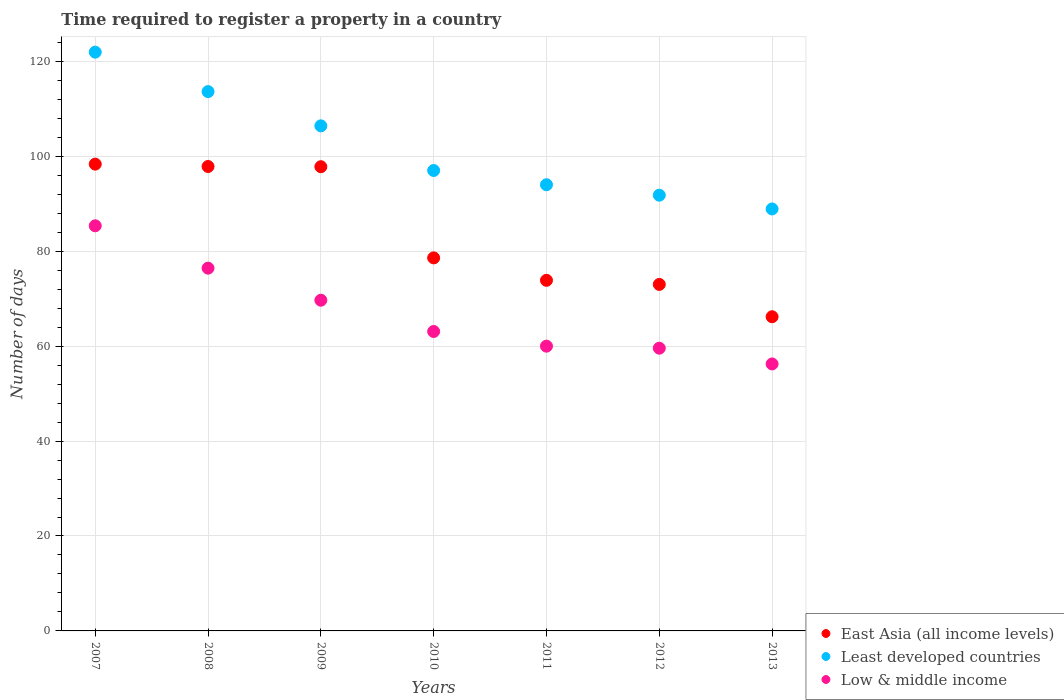How many different coloured dotlines are there?
Keep it short and to the point. 3. What is the number of days required to register a property in East Asia (all income levels) in 2013?
Offer a very short reply. 66.19. Across all years, what is the maximum number of days required to register a property in East Asia (all income levels)?
Your answer should be very brief. 98.34. Across all years, what is the minimum number of days required to register a property in Least developed countries?
Give a very brief answer. 88.9. What is the total number of days required to register a property in Least developed countries in the graph?
Offer a very short reply. 713.65. What is the difference between the number of days required to register a property in East Asia (all income levels) in 2008 and that in 2011?
Your answer should be very brief. 23.98. What is the difference between the number of days required to register a property in Least developed countries in 2011 and the number of days required to register a property in Low & middle income in 2010?
Your answer should be very brief. 30.92. What is the average number of days required to register a property in East Asia (all income levels) per year?
Ensure brevity in your answer.  83.66. In the year 2013, what is the difference between the number of days required to register a property in Least developed countries and number of days required to register a property in Low & middle income?
Provide a short and direct response. 32.65. What is the ratio of the number of days required to register a property in East Asia (all income levels) in 2008 to that in 2010?
Provide a succinct answer. 1.24. Is the difference between the number of days required to register a property in Least developed countries in 2007 and 2013 greater than the difference between the number of days required to register a property in Low & middle income in 2007 and 2013?
Provide a succinct answer. Yes. What is the difference between the highest and the second highest number of days required to register a property in Low & middle income?
Your answer should be compact. 8.92. What is the difference between the highest and the lowest number of days required to register a property in East Asia (all income levels)?
Offer a very short reply. 32.15. Is it the case that in every year, the sum of the number of days required to register a property in Least developed countries and number of days required to register a property in East Asia (all income levels)  is greater than the number of days required to register a property in Low & middle income?
Your answer should be very brief. Yes. Is the number of days required to register a property in Low & middle income strictly greater than the number of days required to register a property in Least developed countries over the years?
Keep it short and to the point. No. How many years are there in the graph?
Your answer should be compact. 7. Does the graph contain grids?
Provide a succinct answer. Yes. How many legend labels are there?
Offer a terse response. 3. How are the legend labels stacked?
Your answer should be compact. Vertical. What is the title of the graph?
Offer a very short reply. Time required to register a property in a country. What is the label or title of the Y-axis?
Offer a terse response. Number of days. What is the Number of days in East Asia (all income levels) in 2007?
Give a very brief answer. 98.34. What is the Number of days in Least developed countries in 2007?
Give a very brief answer. 121.93. What is the Number of days in Low & middle income in 2007?
Make the answer very short. 85.35. What is the Number of days of East Asia (all income levels) in 2008?
Keep it short and to the point. 97.84. What is the Number of days in Least developed countries in 2008?
Your response must be concise. 113.62. What is the Number of days of Low & middle income in 2008?
Your response must be concise. 76.42. What is the Number of days in East Asia (all income levels) in 2009?
Make the answer very short. 97.8. What is the Number of days of Least developed countries in 2009?
Your answer should be very brief. 106.4. What is the Number of days of Low & middle income in 2009?
Offer a terse response. 69.67. What is the Number of days of East Asia (all income levels) in 2010?
Ensure brevity in your answer.  78.59. What is the Number of days of Least developed countries in 2010?
Your answer should be compact. 97. What is the Number of days of Low & middle income in 2010?
Keep it short and to the point. 63.08. What is the Number of days of East Asia (all income levels) in 2011?
Provide a short and direct response. 73.86. What is the Number of days of Least developed countries in 2011?
Your answer should be compact. 94. What is the Number of days of Low & middle income in 2011?
Your answer should be compact. 59.99. What is the Number of days in Least developed countries in 2012?
Offer a very short reply. 91.8. What is the Number of days of Low & middle income in 2012?
Provide a short and direct response. 59.56. What is the Number of days in East Asia (all income levels) in 2013?
Give a very brief answer. 66.19. What is the Number of days in Least developed countries in 2013?
Your answer should be compact. 88.9. What is the Number of days in Low & middle income in 2013?
Provide a short and direct response. 56.25. Across all years, what is the maximum Number of days of East Asia (all income levels)?
Your answer should be very brief. 98.34. Across all years, what is the maximum Number of days in Least developed countries?
Ensure brevity in your answer.  121.93. Across all years, what is the maximum Number of days of Low & middle income?
Your answer should be very brief. 85.35. Across all years, what is the minimum Number of days in East Asia (all income levels)?
Offer a terse response. 66.19. Across all years, what is the minimum Number of days of Least developed countries?
Your response must be concise. 88.9. Across all years, what is the minimum Number of days in Low & middle income?
Provide a succinct answer. 56.25. What is the total Number of days in East Asia (all income levels) in the graph?
Offer a very short reply. 585.62. What is the total Number of days in Least developed countries in the graph?
Your answer should be compact. 713.65. What is the total Number of days in Low & middle income in the graph?
Ensure brevity in your answer.  470.33. What is the difference between the Number of days of Least developed countries in 2007 and that in 2008?
Your answer should be very brief. 8.31. What is the difference between the Number of days in Low & middle income in 2007 and that in 2008?
Provide a succinct answer. 8.92. What is the difference between the Number of days of East Asia (all income levels) in 2007 and that in 2009?
Offer a terse response. 0.55. What is the difference between the Number of days in Least developed countries in 2007 and that in 2009?
Make the answer very short. 15.52. What is the difference between the Number of days of Low & middle income in 2007 and that in 2009?
Provide a short and direct response. 15.68. What is the difference between the Number of days in East Asia (all income levels) in 2007 and that in 2010?
Offer a terse response. 19.75. What is the difference between the Number of days of Least developed countries in 2007 and that in 2010?
Keep it short and to the point. 24.93. What is the difference between the Number of days of Low & middle income in 2007 and that in 2010?
Provide a succinct answer. 22.27. What is the difference between the Number of days of East Asia (all income levels) in 2007 and that in 2011?
Make the answer very short. 24.48. What is the difference between the Number of days of Least developed countries in 2007 and that in 2011?
Make the answer very short. 27.93. What is the difference between the Number of days of Low & middle income in 2007 and that in 2011?
Your answer should be compact. 25.36. What is the difference between the Number of days of East Asia (all income levels) in 2007 and that in 2012?
Keep it short and to the point. 25.34. What is the difference between the Number of days of Least developed countries in 2007 and that in 2012?
Your answer should be very brief. 30.13. What is the difference between the Number of days of Low & middle income in 2007 and that in 2012?
Provide a succinct answer. 25.79. What is the difference between the Number of days of East Asia (all income levels) in 2007 and that in 2013?
Give a very brief answer. 32.15. What is the difference between the Number of days of Least developed countries in 2007 and that in 2013?
Your answer should be very brief. 33.03. What is the difference between the Number of days of Low & middle income in 2007 and that in 2013?
Ensure brevity in your answer.  29.1. What is the difference between the Number of days in East Asia (all income levels) in 2008 and that in 2009?
Provide a short and direct response. 0.05. What is the difference between the Number of days in Least developed countries in 2008 and that in 2009?
Give a very brief answer. 7.21. What is the difference between the Number of days of Low & middle income in 2008 and that in 2009?
Your answer should be very brief. 6.75. What is the difference between the Number of days of East Asia (all income levels) in 2008 and that in 2010?
Your response must be concise. 19.25. What is the difference between the Number of days of Least developed countries in 2008 and that in 2010?
Offer a terse response. 16.62. What is the difference between the Number of days of Low & middle income in 2008 and that in 2010?
Your answer should be very brief. 13.34. What is the difference between the Number of days of East Asia (all income levels) in 2008 and that in 2011?
Offer a very short reply. 23.98. What is the difference between the Number of days in Least developed countries in 2008 and that in 2011?
Offer a terse response. 19.62. What is the difference between the Number of days in Low & middle income in 2008 and that in 2011?
Give a very brief answer. 16.43. What is the difference between the Number of days in East Asia (all income levels) in 2008 and that in 2012?
Make the answer very short. 24.84. What is the difference between the Number of days of Least developed countries in 2008 and that in 2012?
Your answer should be compact. 21.82. What is the difference between the Number of days of Low & middle income in 2008 and that in 2012?
Ensure brevity in your answer.  16.86. What is the difference between the Number of days of East Asia (all income levels) in 2008 and that in 2013?
Ensure brevity in your answer.  31.65. What is the difference between the Number of days in Least developed countries in 2008 and that in 2013?
Keep it short and to the point. 24.72. What is the difference between the Number of days of Low & middle income in 2008 and that in 2013?
Your answer should be very brief. 20.18. What is the difference between the Number of days in East Asia (all income levels) in 2009 and that in 2010?
Keep it short and to the point. 19.2. What is the difference between the Number of days of Least developed countries in 2009 and that in 2010?
Ensure brevity in your answer.  9.4. What is the difference between the Number of days in Low & middle income in 2009 and that in 2010?
Keep it short and to the point. 6.59. What is the difference between the Number of days in East Asia (all income levels) in 2009 and that in 2011?
Your answer should be compact. 23.93. What is the difference between the Number of days in Least developed countries in 2009 and that in 2011?
Offer a terse response. 12.4. What is the difference between the Number of days in Low & middle income in 2009 and that in 2011?
Offer a terse response. 9.68. What is the difference between the Number of days in East Asia (all income levels) in 2009 and that in 2012?
Offer a very short reply. 24.8. What is the difference between the Number of days of Least developed countries in 2009 and that in 2012?
Make the answer very short. 14.61. What is the difference between the Number of days in Low & middle income in 2009 and that in 2012?
Your answer should be very brief. 10.11. What is the difference between the Number of days of East Asia (all income levels) in 2009 and that in 2013?
Your answer should be compact. 31.61. What is the difference between the Number of days of Least developed countries in 2009 and that in 2013?
Offer a very short reply. 17.5. What is the difference between the Number of days of Low & middle income in 2009 and that in 2013?
Your answer should be very brief. 13.43. What is the difference between the Number of days in East Asia (all income levels) in 2010 and that in 2011?
Give a very brief answer. 4.73. What is the difference between the Number of days in Least developed countries in 2010 and that in 2011?
Make the answer very short. 3. What is the difference between the Number of days in Low & middle income in 2010 and that in 2011?
Give a very brief answer. 3.09. What is the difference between the Number of days of East Asia (all income levels) in 2010 and that in 2012?
Your answer should be compact. 5.59. What is the difference between the Number of days of Least developed countries in 2010 and that in 2012?
Offer a very short reply. 5.2. What is the difference between the Number of days of Low & middle income in 2010 and that in 2012?
Your answer should be compact. 3.52. What is the difference between the Number of days in East Asia (all income levels) in 2010 and that in 2013?
Provide a succinct answer. 12.4. What is the difference between the Number of days in Least developed countries in 2010 and that in 2013?
Keep it short and to the point. 8.1. What is the difference between the Number of days in Low & middle income in 2010 and that in 2013?
Your response must be concise. 6.84. What is the difference between the Number of days of East Asia (all income levels) in 2011 and that in 2012?
Your answer should be very brief. 0.86. What is the difference between the Number of days of Least developed countries in 2011 and that in 2012?
Your answer should be very brief. 2.2. What is the difference between the Number of days in Low & middle income in 2011 and that in 2012?
Make the answer very short. 0.43. What is the difference between the Number of days in East Asia (all income levels) in 2011 and that in 2013?
Your response must be concise. 7.68. What is the difference between the Number of days in Least developed countries in 2011 and that in 2013?
Provide a succinct answer. 5.1. What is the difference between the Number of days of Low & middle income in 2011 and that in 2013?
Your answer should be compact. 3.75. What is the difference between the Number of days in East Asia (all income levels) in 2012 and that in 2013?
Provide a succinct answer. 6.81. What is the difference between the Number of days of Least developed countries in 2012 and that in 2013?
Offer a very short reply. 2.9. What is the difference between the Number of days of Low & middle income in 2012 and that in 2013?
Make the answer very short. 3.32. What is the difference between the Number of days of East Asia (all income levels) in 2007 and the Number of days of Least developed countries in 2008?
Your answer should be compact. -15.28. What is the difference between the Number of days of East Asia (all income levels) in 2007 and the Number of days of Low & middle income in 2008?
Provide a succinct answer. 21.92. What is the difference between the Number of days in Least developed countries in 2007 and the Number of days in Low & middle income in 2008?
Provide a succinct answer. 45.5. What is the difference between the Number of days of East Asia (all income levels) in 2007 and the Number of days of Least developed countries in 2009?
Offer a terse response. -8.06. What is the difference between the Number of days of East Asia (all income levels) in 2007 and the Number of days of Low & middle income in 2009?
Your answer should be very brief. 28.67. What is the difference between the Number of days in Least developed countries in 2007 and the Number of days in Low & middle income in 2009?
Make the answer very short. 52.26. What is the difference between the Number of days of East Asia (all income levels) in 2007 and the Number of days of Least developed countries in 2010?
Your response must be concise. 1.34. What is the difference between the Number of days of East Asia (all income levels) in 2007 and the Number of days of Low & middle income in 2010?
Provide a succinct answer. 35.26. What is the difference between the Number of days in Least developed countries in 2007 and the Number of days in Low & middle income in 2010?
Your answer should be compact. 58.85. What is the difference between the Number of days in East Asia (all income levels) in 2007 and the Number of days in Least developed countries in 2011?
Give a very brief answer. 4.34. What is the difference between the Number of days of East Asia (all income levels) in 2007 and the Number of days of Low & middle income in 2011?
Your response must be concise. 38.35. What is the difference between the Number of days of Least developed countries in 2007 and the Number of days of Low & middle income in 2011?
Your answer should be very brief. 61.94. What is the difference between the Number of days of East Asia (all income levels) in 2007 and the Number of days of Least developed countries in 2012?
Keep it short and to the point. 6.55. What is the difference between the Number of days in East Asia (all income levels) in 2007 and the Number of days in Low & middle income in 2012?
Provide a short and direct response. 38.78. What is the difference between the Number of days of Least developed countries in 2007 and the Number of days of Low & middle income in 2012?
Provide a succinct answer. 62.36. What is the difference between the Number of days of East Asia (all income levels) in 2007 and the Number of days of Least developed countries in 2013?
Your answer should be very brief. 9.44. What is the difference between the Number of days of East Asia (all income levels) in 2007 and the Number of days of Low & middle income in 2013?
Offer a very short reply. 42.1. What is the difference between the Number of days in Least developed countries in 2007 and the Number of days in Low & middle income in 2013?
Your answer should be very brief. 65.68. What is the difference between the Number of days in East Asia (all income levels) in 2008 and the Number of days in Least developed countries in 2009?
Offer a very short reply. -8.56. What is the difference between the Number of days of East Asia (all income levels) in 2008 and the Number of days of Low & middle income in 2009?
Provide a short and direct response. 28.17. What is the difference between the Number of days of Least developed countries in 2008 and the Number of days of Low & middle income in 2009?
Keep it short and to the point. 43.95. What is the difference between the Number of days in East Asia (all income levels) in 2008 and the Number of days in Least developed countries in 2010?
Your response must be concise. 0.84. What is the difference between the Number of days of East Asia (all income levels) in 2008 and the Number of days of Low & middle income in 2010?
Make the answer very short. 34.76. What is the difference between the Number of days in Least developed countries in 2008 and the Number of days in Low & middle income in 2010?
Make the answer very short. 50.54. What is the difference between the Number of days in East Asia (all income levels) in 2008 and the Number of days in Least developed countries in 2011?
Your answer should be very brief. 3.84. What is the difference between the Number of days in East Asia (all income levels) in 2008 and the Number of days in Low & middle income in 2011?
Your response must be concise. 37.85. What is the difference between the Number of days of Least developed countries in 2008 and the Number of days of Low & middle income in 2011?
Provide a short and direct response. 53.63. What is the difference between the Number of days of East Asia (all income levels) in 2008 and the Number of days of Least developed countries in 2012?
Provide a succinct answer. 6.05. What is the difference between the Number of days of East Asia (all income levels) in 2008 and the Number of days of Low & middle income in 2012?
Offer a terse response. 38.28. What is the difference between the Number of days in Least developed countries in 2008 and the Number of days in Low & middle income in 2012?
Make the answer very short. 54.05. What is the difference between the Number of days in East Asia (all income levels) in 2008 and the Number of days in Least developed countries in 2013?
Offer a very short reply. 8.94. What is the difference between the Number of days of East Asia (all income levels) in 2008 and the Number of days of Low & middle income in 2013?
Your answer should be very brief. 41.6. What is the difference between the Number of days of Least developed countries in 2008 and the Number of days of Low & middle income in 2013?
Offer a terse response. 57.37. What is the difference between the Number of days of East Asia (all income levels) in 2009 and the Number of days of Least developed countries in 2010?
Make the answer very short. 0.8. What is the difference between the Number of days of East Asia (all income levels) in 2009 and the Number of days of Low & middle income in 2010?
Keep it short and to the point. 34.71. What is the difference between the Number of days in Least developed countries in 2009 and the Number of days in Low & middle income in 2010?
Ensure brevity in your answer.  43.32. What is the difference between the Number of days in East Asia (all income levels) in 2009 and the Number of days in Least developed countries in 2011?
Your response must be concise. 3.8. What is the difference between the Number of days of East Asia (all income levels) in 2009 and the Number of days of Low & middle income in 2011?
Your answer should be very brief. 37.8. What is the difference between the Number of days of Least developed countries in 2009 and the Number of days of Low & middle income in 2011?
Ensure brevity in your answer.  46.41. What is the difference between the Number of days in East Asia (all income levels) in 2009 and the Number of days in Least developed countries in 2012?
Your response must be concise. 6. What is the difference between the Number of days of East Asia (all income levels) in 2009 and the Number of days of Low & middle income in 2012?
Make the answer very short. 38.23. What is the difference between the Number of days in Least developed countries in 2009 and the Number of days in Low & middle income in 2012?
Offer a very short reply. 46.84. What is the difference between the Number of days of East Asia (all income levels) in 2009 and the Number of days of Least developed countries in 2013?
Offer a terse response. 8.9. What is the difference between the Number of days in East Asia (all income levels) in 2009 and the Number of days in Low & middle income in 2013?
Your answer should be very brief. 41.55. What is the difference between the Number of days in Least developed countries in 2009 and the Number of days in Low & middle income in 2013?
Give a very brief answer. 50.16. What is the difference between the Number of days of East Asia (all income levels) in 2010 and the Number of days of Least developed countries in 2011?
Provide a succinct answer. -15.41. What is the difference between the Number of days of East Asia (all income levels) in 2010 and the Number of days of Low & middle income in 2011?
Provide a short and direct response. 18.6. What is the difference between the Number of days of Least developed countries in 2010 and the Number of days of Low & middle income in 2011?
Your answer should be compact. 37.01. What is the difference between the Number of days in East Asia (all income levels) in 2010 and the Number of days in Least developed countries in 2012?
Ensure brevity in your answer.  -13.2. What is the difference between the Number of days of East Asia (all income levels) in 2010 and the Number of days of Low & middle income in 2012?
Give a very brief answer. 19.03. What is the difference between the Number of days of Least developed countries in 2010 and the Number of days of Low & middle income in 2012?
Keep it short and to the point. 37.44. What is the difference between the Number of days in East Asia (all income levels) in 2010 and the Number of days in Least developed countries in 2013?
Your answer should be compact. -10.31. What is the difference between the Number of days of East Asia (all income levels) in 2010 and the Number of days of Low & middle income in 2013?
Ensure brevity in your answer.  22.35. What is the difference between the Number of days in Least developed countries in 2010 and the Number of days in Low & middle income in 2013?
Provide a short and direct response. 40.75. What is the difference between the Number of days in East Asia (all income levels) in 2011 and the Number of days in Least developed countries in 2012?
Your response must be concise. -17.93. What is the difference between the Number of days in East Asia (all income levels) in 2011 and the Number of days in Low & middle income in 2012?
Keep it short and to the point. 14.3. What is the difference between the Number of days of Least developed countries in 2011 and the Number of days of Low & middle income in 2012?
Ensure brevity in your answer.  34.44. What is the difference between the Number of days in East Asia (all income levels) in 2011 and the Number of days in Least developed countries in 2013?
Ensure brevity in your answer.  -15.04. What is the difference between the Number of days in East Asia (all income levels) in 2011 and the Number of days in Low & middle income in 2013?
Give a very brief answer. 17.62. What is the difference between the Number of days in Least developed countries in 2011 and the Number of days in Low & middle income in 2013?
Ensure brevity in your answer.  37.75. What is the difference between the Number of days in East Asia (all income levels) in 2012 and the Number of days in Least developed countries in 2013?
Provide a succinct answer. -15.9. What is the difference between the Number of days of East Asia (all income levels) in 2012 and the Number of days of Low & middle income in 2013?
Provide a succinct answer. 16.75. What is the difference between the Number of days of Least developed countries in 2012 and the Number of days of Low & middle income in 2013?
Your response must be concise. 35.55. What is the average Number of days in East Asia (all income levels) per year?
Give a very brief answer. 83.66. What is the average Number of days of Least developed countries per year?
Ensure brevity in your answer.  101.95. What is the average Number of days in Low & middle income per year?
Your answer should be very brief. 67.19. In the year 2007, what is the difference between the Number of days in East Asia (all income levels) and Number of days in Least developed countries?
Keep it short and to the point. -23.59. In the year 2007, what is the difference between the Number of days of East Asia (all income levels) and Number of days of Low & middle income?
Make the answer very short. 12.99. In the year 2007, what is the difference between the Number of days in Least developed countries and Number of days in Low & middle income?
Your answer should be compact. 36.58. In the year 2008, what is the difference between the Number of days in East Asia (all income levels) and Number of days in Least developed countries?
Make the answer very short. -15.78. In the year 2008, what is the difference between the Number of days in East Asia (all income levels) and Number of days in Low & middle income?
Ensure brevity in your answer.  21.42. In the year 2008, what is the difference between the Number of days of Least developed countries and Number of days of Low & middle income?
Your response must be concise. 37.19. In the year 2009, what is the difference between the Number of days of East Asia (all income levels) and Number of days of Least developed countries?
Offer a terse response. -8.61. In the year 2009, what is the difference between the Number of days of East Asia (all income levels) and Number of days of Low & middle income?
Provide a short and direct response. 28.12. In the year 2009, what is the difference between the Number of days of Least developed countries and Number of days of Low & middle income?
Your response must be concise. 36.73. In the year 2010, what is the difference between the Number of days in East Asia (all income levels) and Number of days in Least developed countries?
Give a very brief answer. -18.41. In the year 2010, what is the difference between the Number of days in East Asia (all income levels) and Number of days in Low & middle income?
Provide a succinct answer. 15.51. In the year 2010, what is the difference between the Number of days in Least developed countries and Number of days in Low & middle income?
Provide a short and direct response. 33.92. In the year 2011, what is the difference between the Number of days of East Asia (all income levels) and Number of days of Least developed countries?
Ensure brevity in your answer.  -20.14. In the year 2011, what is the difference between the Number of days of East Asia (all income levels) and Number of days of Low & middle income?
Your answer should be compact. 13.87. In the year 2011, what is the difference between the Number of days of Least developed countries and Number of days of Low & middle income?
Keep it short and to the point. 34.01. In the year 2012, what is the difference between the Number of days of East Asia (all income levels) and Number of days of Least developed countries?
Your response must be concise. -18.8. In the year 2012, what is the difference between the Number of days of East Asia (all income levels) and Number of days of Low & middle income?
Your response must be concise. 13.44. In the year 2012, what is the difference between the Number of days of Least developed countries and Number of days of Low & middle income?
Your response must be concise. 32.23. In the year 2013, what is the difference between the Number of days of East Asia (all income levels) and Number of days of Least developed countries?
Ensure brevity in your answer.  -22.71. In the year 2013, what is the difference between the Number of days of East Asia (all income levels) and Number of days of Low & middle income?
Offer a very short reply. 9.94. In the year 2013, what is the difference between the Number of days in Least developed countries and Number of days in Low & middle income?
Your answer should be very brief. 32.65. What is the ratio of the Number of days in East Asia (all income levels) in 2007 to that in 2008?
Ensure brevity in your answer.  1.01. What is the ratio of the Number of days of Least developed countries in 2007 to that in 2008?
Make the answer very short. 1.07. What is the ratio of the Number of days of Low & middle income in 2007 to that in 2008?
Your response must be concise. 1.12. What is the ratio of the Number of days of East Asia (all income levels) in 2007 to that in 2009?
Give a very brief answer. 1.01. What is the ratio of the Number of days in Least developed countries in 2007 to that in 2009?
Make the answer very short. 1.15. What is the ratio of the Number of days in Low & middle income in 2007 to that in 2009?
Give a very brief answer. 1.23. What is the ratio of the Number of days of East Asia (all income levels) in 2007 to that in 2010?
Ensure brevity in your answer.  1.25. What is the ratio of the Number of days in Least developed countries in 2007 to that in 2010?
Make the answer very short. 1.26. What is the ratio of the Number of days in Low & middle income in 2007 to that in 2010?
Your answer should be compact. 1.35. What is the ratio of the Number of days of East Asia (all income levels) in 2007 to that in 2011?
Offer a terse response. 1.33. What is the ratio of the Number of days of Least developed countries in 2007 to that in 2011?
Offer a terse response. 1.3. What is the ratio of the Number of days in Low & middle income in 2007 to that in 2011?
Give a very brief answer. 1.42. What is the ratio of the Number of days in East Asia (all income levels) in 2007 to that in 2012?
Ensure brevity in your answer.  1.35. What is the ratio of the Number of days in Least developed countries in 2007 to that in 2012?
Provide a succinct answer. 1.33. What is the ratio of the Number of days of Low & middle income in 2007 to that in 2012?
Give a very brief answer. 1.43. What is the ratio of the Number of days of East Asia (all income levels) in 2007 to that in 2013?
Provide a short and direct response. 1.49. What is the ratio of the Number of days of Least developed countries in 2007 to that in 2013?
Provide a short and direct response. 1.37. What is the ratio of the Number of days in Low & middle income in 2007 to that in 2013?
Your answer should be very brief. 1.52. What is the ratio of the Number of days in East Asia (all income levels) in 2008 to that in 2009?
Your answer should be very brief. 1. What is the ratio of the Number of days of Least developed countries in 2008 to that in 2009?
Ensure brevity in your answer.  1.07. What is the ratio of the Number of days of Low & middle income in 2008 to that in 2009?
Ensure brevity in your answer.  1.1. What is the ratio of the Number of days of East Asia (all income levels) in 2008 to that in 2010?
Give a very brief answer. 1.24. What is the ratio of the Number of days of Least developed countries in 2008 to that in 2010?
Provide a succinct answer. 1.17. What is the ratio of the Number of days in Low & middle income in 2008 to that in 2010?
Your response must be concise. 1.21. What is the ratio of the Number of days of East Asia (all income levels) in 2008 to that in 2011?
Your response must be concise. 1.32. What is the ratio of the Number of days in Least developed countries in 2008 to that in 2011?
Keep it short and to the point. 1.21. What is the ratio of the Number of days in Low & middle income in 2008 to that in 2011?
Offer a terse response. 1.27. What is the ratio of the Number of days in East Asia (all income levels) in 2008 to that in 2012?
Offer a very short reply. 1.34. What is the ratio of the Number of days in Least developed countries in 2008 to that in 2012?
Make the answer very short. 1.24. What is the ratio of the Number of days in Low & middle income in 2008 to that in 2012?
Offer a very short reply. 1.28. What is the ratio of the Number of days of East Asia (all income levels) in 2008 to that in 2013?
Offer a terse response. 1.48. What is the ratio of the Number of days in Least developed countries in 2008 to that in 2013?
Provide a short and direct response. 1.28. What is the ratio of the Number of days in Low & middle income in 2008 to that in 2013?
Provide a succinct answer. 1.36. What is the ratio of the Number of days in East Asia (all income levels) in 2009 to that in 2010?
Offer a very short reply. 1.24. What is the ratio of the Number of days of Least developed countries in 2009 to that in 2010?
Your answer should be compact. 1.1. What is the ratio of the Number of days of Low & middle income in 2009 to that in 2010?
Give a very brief answer. 1.1. What is the ratio of the Number of days in East Asia (all income levels) in 2009 to that in 2011?
Your answer should be very brief. 1.32. What is the ratio of the Number of days of Least developed countries in 2009 to that in 2011?
Make the answer very short. 1.13. What is the ratio of the Number of days in Low & middle income in 2009 to that in 2011?
Offer a terse response. 1.16. What is the ratio of the Number of days of East Asia (all income levels) in 2009 to that in 2012?
Make the answer very short. 1.34. What is the ratio of the Number of days in Least developed countries in 2009 to that in 2012?
Provide a short and direct response. 1.16. What is the ratio of the Number of days of Low & middle income in 2009 to that in 2012?
Your answer should be compact. 1.17. What is the ratio of the Number of days in East Asia (all income levels) in 2009 to that in 2013?
Your response must be concise. 1.48. What is the ratio of the Number of days of Least developed countries in 2009 to that in 2013?
Your answer should be compact. 1.2. What is the ratio of the Number of days of Low & middle income in 2009 to that in 2013?
Give a very brief answer. 1.24. What is the ratio of the Number of days of East Asia (all income levels) in 2010 to that in 2011?
Offer a terse response. 1.06. What is the ratio of the Number of days of Least developed countries in 2010 to that in 2011?
Make the answer very short. 1.03. What is the ratio of the Number of days in Low & middle income in 2010 to that in 2011?
Give a very brief answer. 1.05. What is the ratio of the Number of days of East Asia (all income levels) in 2010 to that in 2012?
Your response must be concise. 1.08. What is the ratio of the Number of days in Least developed countries in 2010 to that in 2012?
Offer a terse response. 1.06. What is the ratio of the Number of days in Low & middle income in 2010 to that in 2012?
Provide a short and direct response. 1.06. What is the ratio of the Number of days of East Asia (all income levels) in 2010 to that in 2013?
Keep it short and to the point. 1.19. What is the ratio of the Number of days of Least developed countries in 2010 to that in 2013?
Your answer should be compact. 1.09. What is the ratio of the Number of days in Low & middle income in 2010 to that in 2013?
Give a very brief answer. 1.12. What is the ratio of the Number of days of East Asia (all income levels) in 2011 to that in 2012?
Offer a terse response. 1.01. What is the ratio of the Number of days of Least developed countries in 2011 to that in 2012?
Make the answer very short. 1.02. What is the ratio of the Number of days of East Asia (all income levels) in 2011 to that in 2013?
Make the answer very short. 1.12. What is the ratio of the Number of days of Least developed countries in 2011 to that in 2013?
Ensure brevity in your answer.  1.06. What is the ratio of the Number of days of Low & middle income in 2011 to that in 2013?
Provide a short and direct response. 1.07. What is the ratio of the Number of days of East Asia (all income levels) in 2012 to that in 2013?
Your answer should be very brief. 1.1. What is the ratio of the Number of days of Least developed countries in 2012 to that in 2013?
Your response must be concise. 1.03. What is the ratio of the Number of days in Low & middle income in 2012 to that in 2013?
Provide a short and direct response. 1.06. What is the difference between the highest and the second highest Number of days of Least developed countries?
Your answer should be compact. 8.31. What is the difference between the highest and the second highest Number of days of Low & middle income?
Keep it short and to the point. 8.92. What is the difference between the highest and the lowest Number of days of East Asia (all income levels)?
Give a very brief answer. 32.15. What is the difference between the highest and the lowest Number of days in Least developed countries?
Keep it short and to the point. 33.03. What is the difference between the highest and the lowest Number of days of Low & middle income?
Provide a succinct answer. 29.1. 